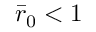<formula> <loc_0><loc_0><loc_500><loc_500>\bar { r } _ { 0 } < 1</formula> 